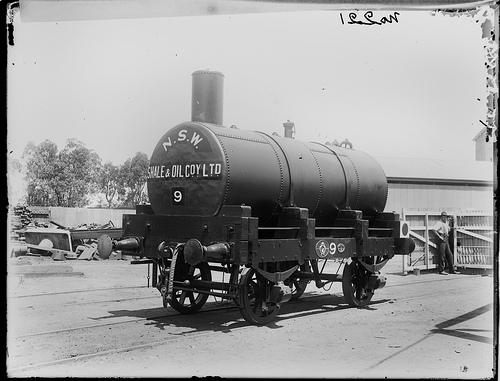Are there any people in the scene?
Be succinct. Yes. Is this a recent photo?
Give a very brief answer. No. What number do you see?
Answer briefly. 9. What number is on the train?
Answer briefly. 9. 